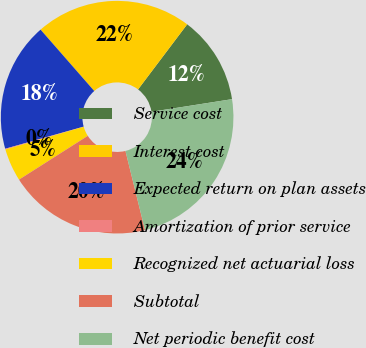Convert chart. <chart><loc_0><loc_0><loc_500><loc_500><pie_chart><fcel>Service cost<fcel>Interest cost<fcel>Expected return on plan assets<fcel>Amortization of prior service<fcel>Recognized net actuarial loss<fcel>Subtotal<fcel>Net periodic benefit cost<nl><fcel>12.24%<fcel>21.73%<fcel>17.94%<fcel>0.1%<fcel>4.55%<fcel>19.83%<fcel>23.63%<nl></chart> 